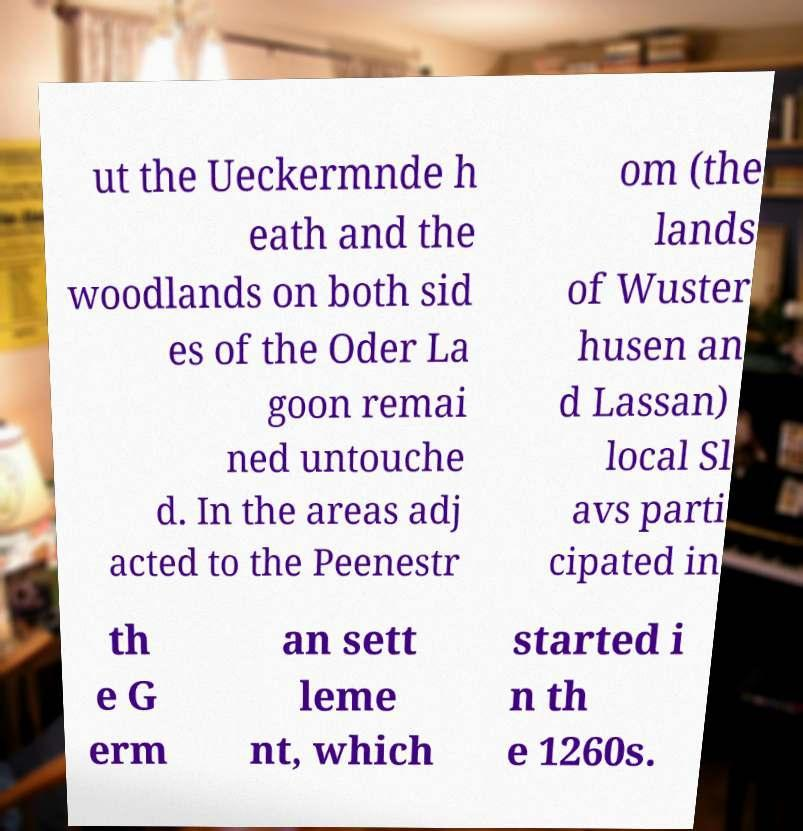Can you accurately transcribe the text from the provided image for me? ut the Ueckermnde h eath and the woodlands on both sid es of the Oder La goon remai ned untouche d. In the areas adj acted to the Peenestr om (the lands of Wuster husen an d Lassan) local Sl avs parti cipated in th e G erm an sett leme nt, which started i n th e 1260s. 